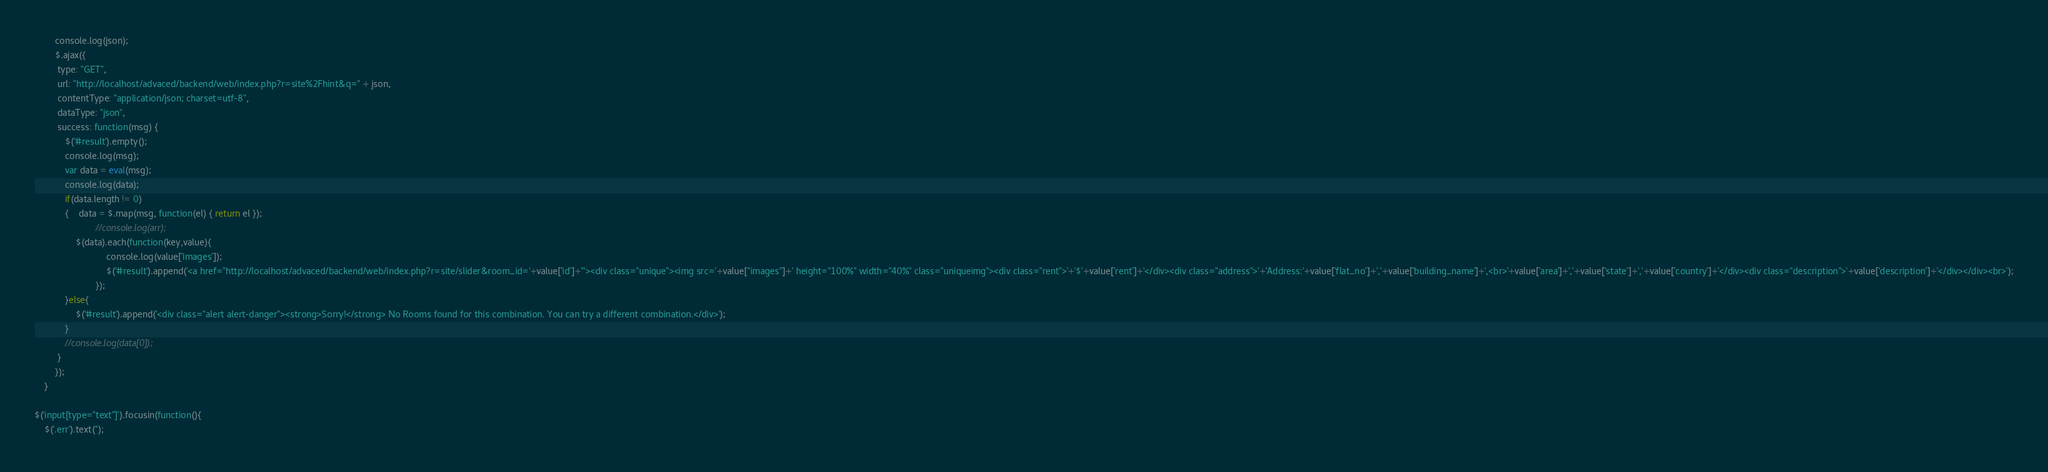<code> <loc_0><loc_0><loc_500><loc_500><_JavaScript_>		console.log(json);
        $.ajax({
		 type: "GET",
		 url: "http://localhost/advaced/backend/web/index.php?r=site%2Fhint&q=" + json,
		 contentType: "application/json; charset=utf-8",
		 dataType: "json",
		 success: function(msg) {
		 	$('#result').empty();
		 	console.log(msg);
		 	var data = eval(msg);
		 	console.log(data);
		 	if(data.length != 0)
		 	{	data = $.map(msg, function(el) { return el });
		 			 	//console.log(arr);
 			 	$(data).each(function(key,value){
		 			 		console.log(value['images']);
		 			 		$('#result').append('<a href="http://localhost/advaced/backend/web/index.php?r=site/slider&room_id='+value['id']+'"><div class="unique"><img src='+value["images"]+' height="100%" width="40%" class="uniqueimg"><div class="rent">'+'$'+value['rent']+'</div><div class="address">'+'Address:'+value['flat_no']+','+value['building_name']+',<br>'+value['area']+','+value['state']+','+value['country']+'</div><div class="description">'+value['description']+'</div></div><br>');
		 			 	});
		 	}else{
		 		$('#result').append('<div class="alert alert-danger"><strong>Sorry!</strong> No Rooms found for this combination. You can try a different combination.</div>');
		 	}
		 	//console.log(data[0]);
		 }
		});
	}

$('input[type="text"]').focusin(function(){
	$('.err').text('');</code> 